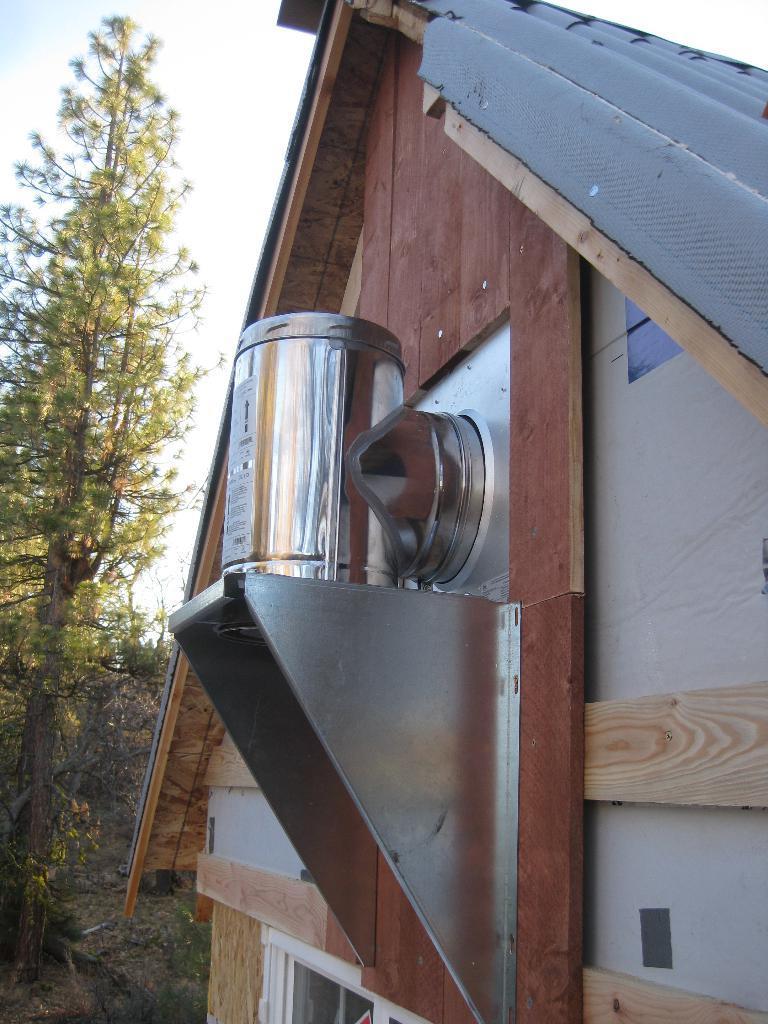Describe this image in one or two sentences. In the foreground of the picture there is a building. In the center there is an iron object. On the left there are trees. 